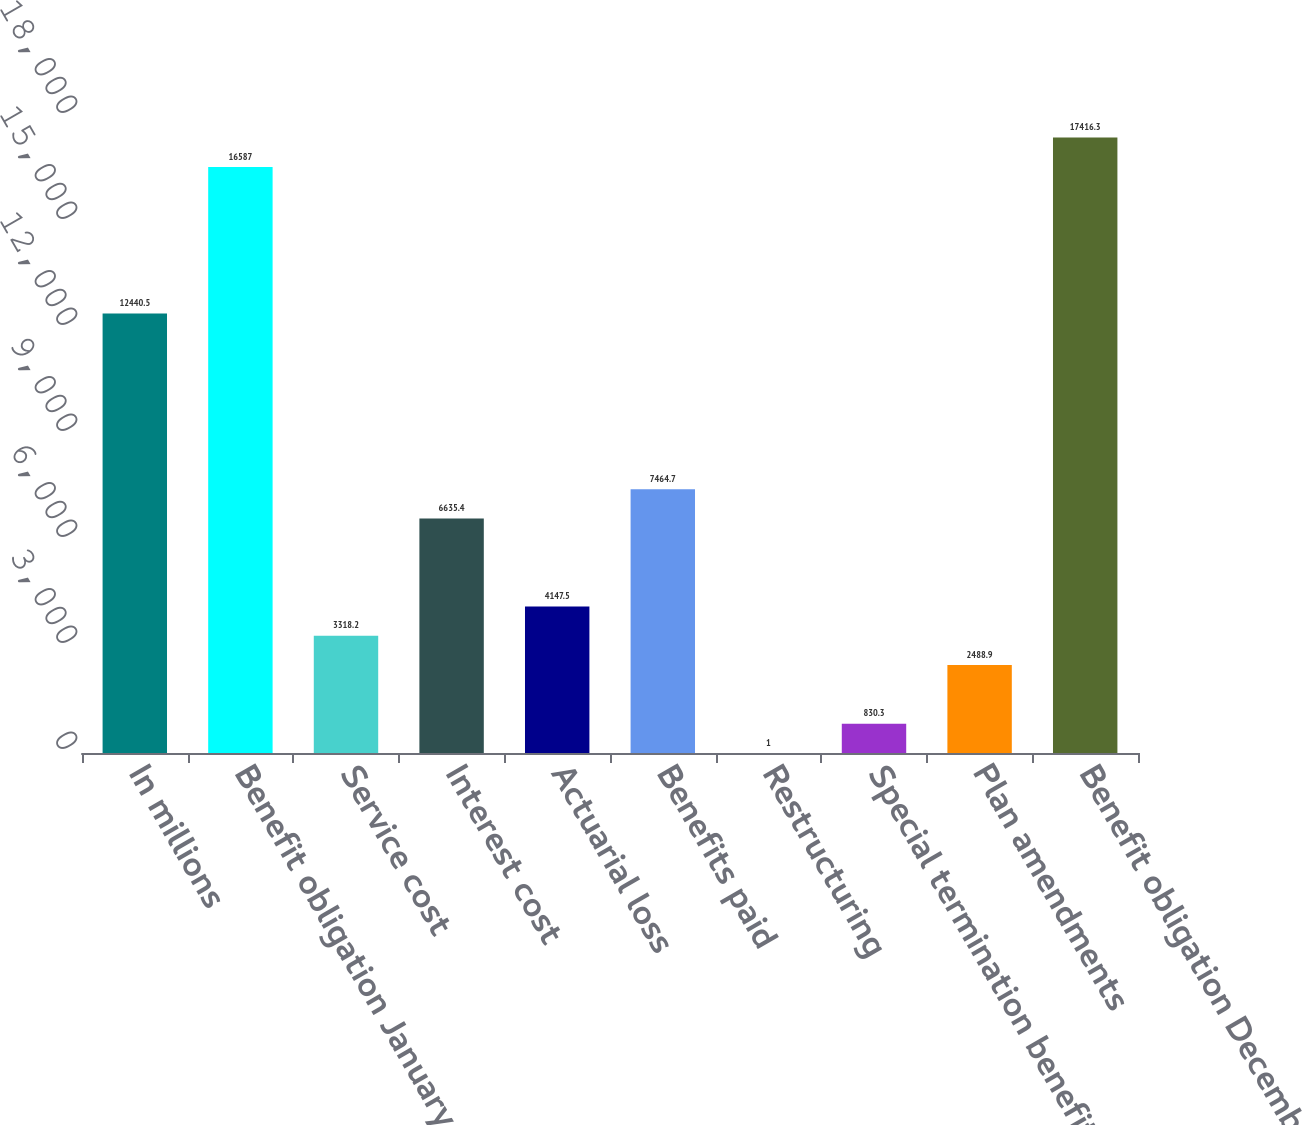<chart> <loc_0><loc_0><loc_500><loc_500><bar_chart><fcel>In millions<fcel>Benefit obligation January 1<fcel>Service cost<fcel>Interest cost<fcel>Actuarial loss<fcel>Benefits paid<fcel>Restructuring<fcel>Special termination benefits<fcel>Plan amendments<fcel>Benefit obligation December 31<nl><fcel>12440.5<fcel>16587<fcel>3318.2<fcel>6635.4<fcel>4147.5<fcel>7464.7<fcel>1<fcel>830.3<fcel>2488.9<fcel>17416.3<nl></chart> 